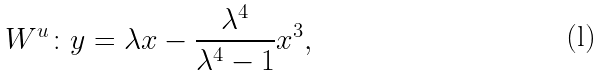<formula> <loc_0><loc_0><loc_500><loc_500>W ^ { u } \colon y = \lambda x - \frac { \lambda ^ { 4 } } { \lambda ^ { 4 } - 1 } x ^ { 3 } ,</formula> 